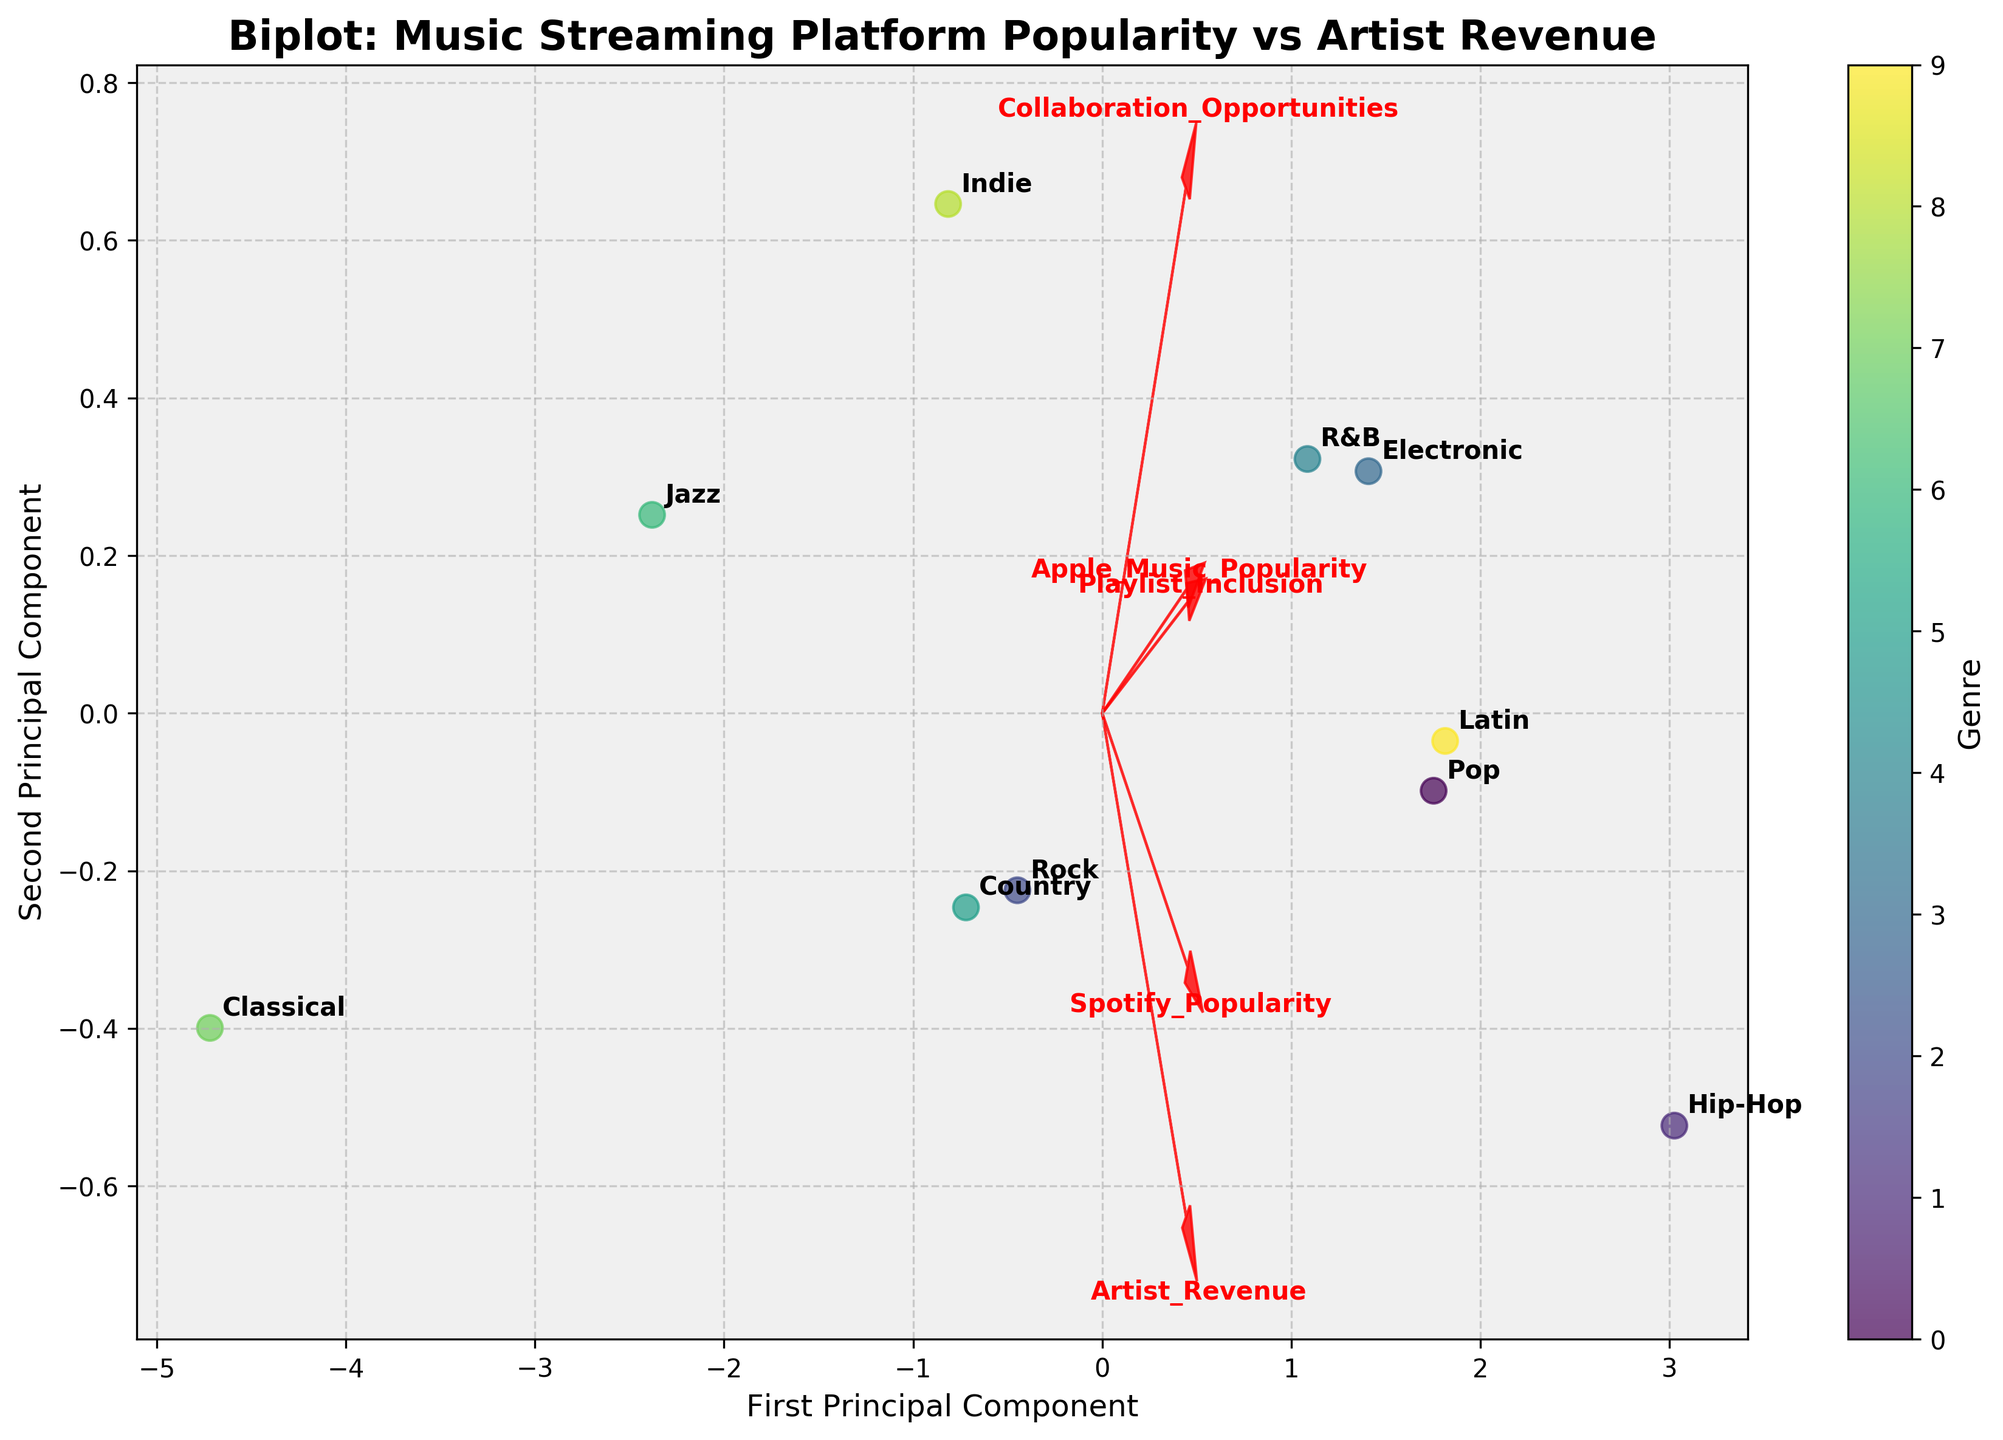What is the title of the figure? The title is usually displayed prominently at the top of the figure. In this figure, it is bold and centered.
Answer: Biplot: Music Streaming Platform Popularity vs Artist Revenue What does the color bar on the right side of the plot represent? The color bar provides a visual guide to understand which color corresponds to which genre. The various colors indicate different genres.
Answer: Genre Which genre appears at the furthest point on the right side of the plot? By looking at the annotation labels on the rightmost side of the plot, we can identify the genre positioned furthest to the right.
Answer: Hip-Hop Which two genres are closest to each other on the plot? By examining the annotations closely, the two genres positioned closest together can be determined.
Answer: Classical and Jazz Does "Pop" have a higher value in the first principal component or the second one? By locating "Pop" on the plot and seeing which axis it extends further along, we can determine its higher value.
Answer: First principal component How does the 'Artist_Revenue' vector orient compared to the 'Playlist_Inclusion' vector? By observing the red arrows representing these features, we can identify the direction and angle of each vector to determine their orientation.
Answer: Artist_Revenue is more horizontal; Playlist_Inclusion is more vertical Which genre exhibits a similar pattern in streaming platform popularity based on its position on the plot? Genres close to each other likely show a similar pattern in their streaming platform popularity, as indicated by their similar locations on the plot.
Answer: Pop and Latin Rank the genres from highest to lowest based on the 'Spotify_Popularity' vector direction and their positions. By projecting the genre points onto the 'Spotify_Popularity' vector and estimating their distances, we can rank them.
Answer: Hip-Hop, Pop, Latin, Electronic, R&B, Indie, Rock, Country, Jazz, Classical Which feature vector has the steepest slope in the second principal component compared to the first one? By comparing the angles of each red arrow relative to the first and second principal components, we identify the steepest slope.
Answer: Collaboration_Opportunities 